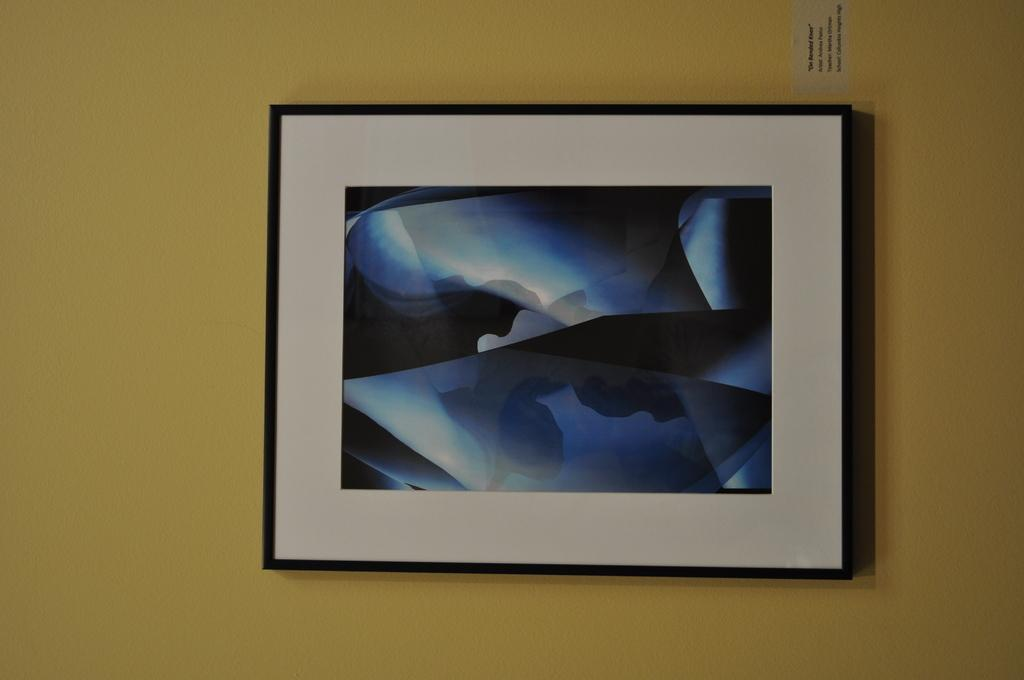What is present in the image that has a defined border or edge? There is a frame in the image. What can be seen on the wall in the image? There is a sticker on the wall in the image. Can you describe the frog's desire to explore the sea in the image? There is no frog or sea present in the image; it only features a frame and a sticker on the wall. 